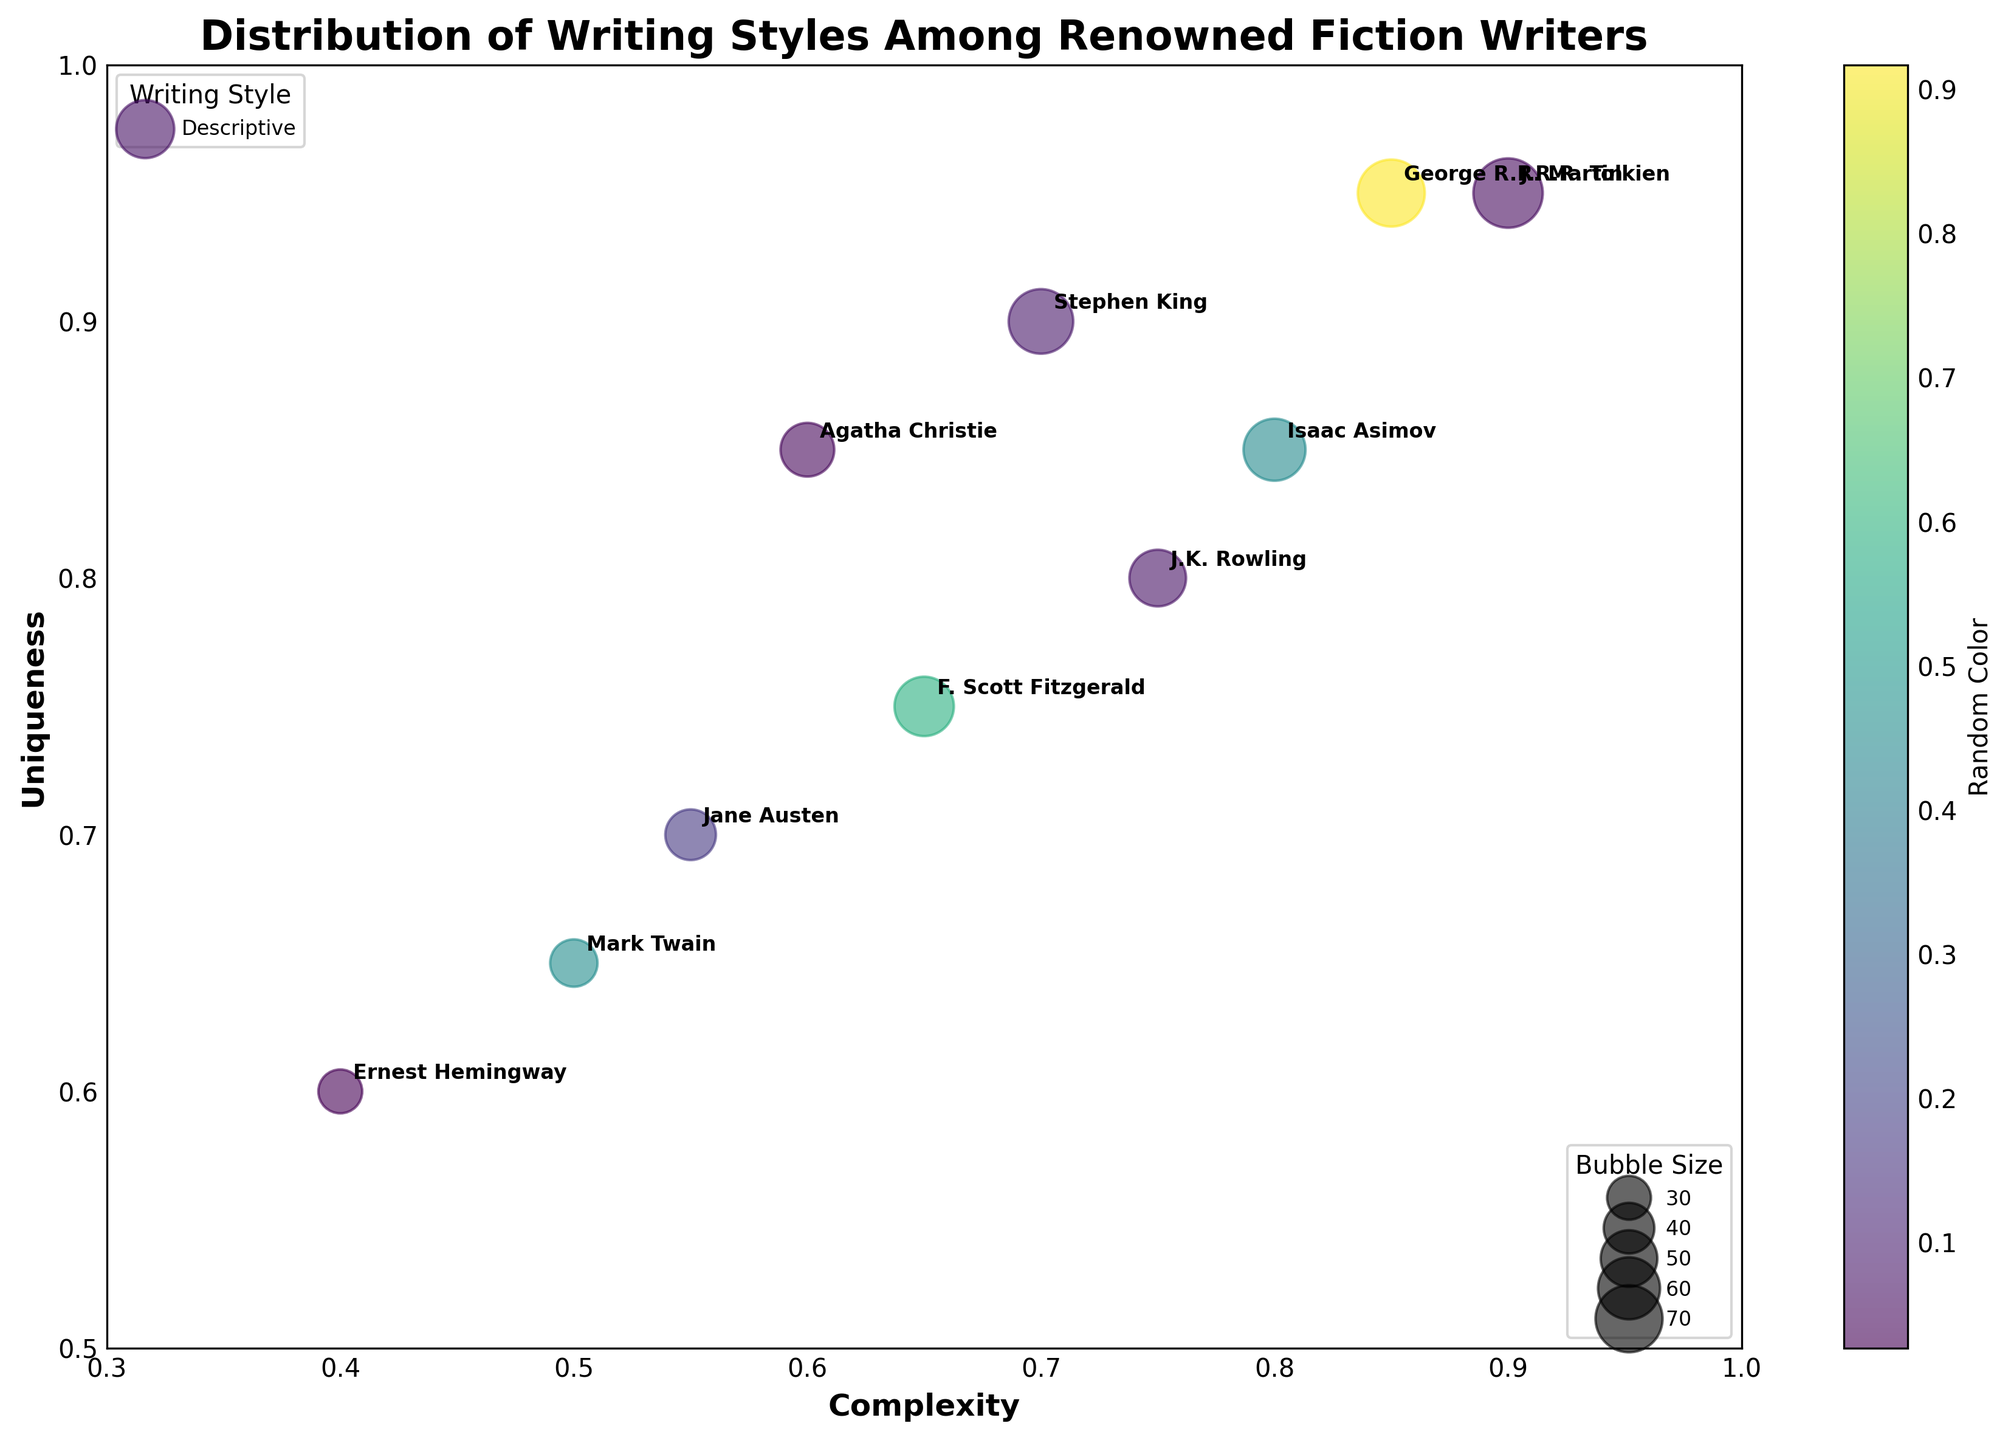What's the title of the figure? The title of the figure is usually located at the top, and in this case, the title is set to 'Distribution of Writing Styles Among Renowned Fiction Writers'.
Answer: Distribution of Writing Styles Among Renowned Fiction Writers Which writer has the highest complexity value? To find the writer with the highest complexity, look for the bubble farthest to the right on the x-axis, which is Complexity. J.R.R. Tolkien's bubble is at 0.9.
Answer: J.R.R. Tolkien What is the range of uniqueness values displayed? The range of uniqueness values spans from the minimum to the maximum values on the y-axis (Uniqueness). The minimum is 0.60 (Ernest Hemingway), and the maximum is 0.95 (J.R.R. Tolkien and George R.R. Martin).
Answer: 0.60 to 0.95 Which writer has the largest bubble, and what does it represent? The largest bubble can be identified visually as the one with the biggest area, which, in this case, belongs to J.R.R. Tolkien. The size represents the BubbleSize value, which is 75 for J.R.R. Tolkien.
Answer: J.R.R. Tolkien How many writers have a complexity value of 0.75 or higher? Count the bubbles placed at or beyond 0.75 on the x-axis. The writers are J.K. Rowling, George R.R. Martin, Isaac Asimov, and J.R.R. Tolkien.
Answer: 4 writers Who is closer in writing style to Stephen King, J.K. Rowling, or Agatha Christie? Compare the distances of the bubbles representing Stephen King to those of J.K. Rowling and Agatha Christie on both x-axis (Complexity) and y-axis (Uniqueness). Agatha Christie's bubble is closer in both axes.
Answer: Agatha Christie Which two writers have the same value for uniqueness? By inspecting the y-axis, the two writers whose bubbles align horizontally indicate equal uniqueness. George R.R. Martin and J.R.R. Tolkien both have a uniqueness value of 0.95.
Answer: George R.R. Martin and J.R.R. Tolkien Who are the writers with the least uniqueness, and what is their value? The writer with the lowest bubble on the y-axis has the least uniqueness. Ernest Hemingway has the smallest value at 0.60.
Answer: Ernest Hemingway What is the difference in complexity between Isaac Asimov and Agatha Christie? Identify their positions on the x-axis. Isaac Asimov is at 0.80, and Agatha Christie is at 0.60. Subtract Agatha Christie's value from Isaac Asimov's. 0.80 - 0.60 = 0.20
Answer: 0.20 Whose bubble is positioned closest to the y-axis value of 0.70? Find the writer whose bubble is closest to the y-axis at 0.70. Jane Austen's bubble is positioned at the exact value of 0.70 on the y-axis.
Answer: Jane Austen 